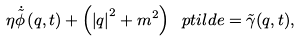<formula> <loc_0><loc_0><loc_500><loc_500>\eta \dot { \tilde { \phi } } \left ( { q } , t \right ) + \left ( \left | { q } \right | ^ { 2 } + m ^ { 2 } \right ) \ p t i l d e = \tilde { \gamma } ( { q } , t ) ,</formula> 